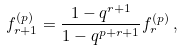<formula> <loc_0><loc_0><loc_500><loc_500>f _ { r + 1 } ^ { ( p ) } = \frac { 1 - q ^ { r + 1 } } { 1 - q ^ { p + r + 1 } } f _ { r } ^ { ( p ) } \, ,</formula> 